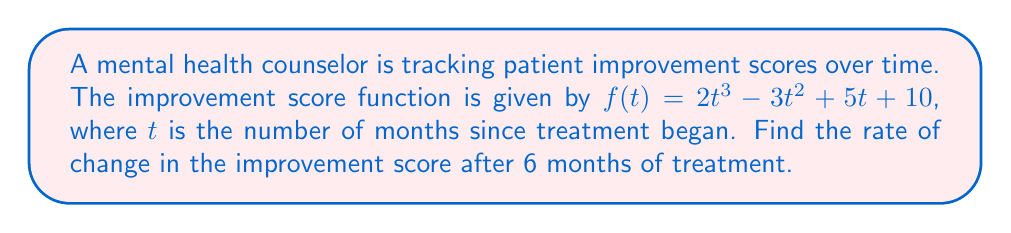Can you answer this question? To find the rate of change in the improvement score after 6 months, we need to follow these steps:

1. Find the derivative of the improvement score function $f(t)$.
   The derivative represents the rate of change of the function.

   $$f'(t) = \frac{d}{dt}(2t^3 - 3t^2 + 5t + 10)$$
   $$f'(t) = 6t^2 - 6t + 5$$

2. Evaluate the derivative at $t = 6$ months.

   $$f'(6) = 6(6)^2 - 6(6) + 5$$
   $$f'(6) = 6(36) - 36 + 5$$
   $$f'(6) = 216 - 36 + 5$$
   $$f'(6) = 185$$

The rate of change after 6 months is 185 points per month.
Answer: 185 points/month 